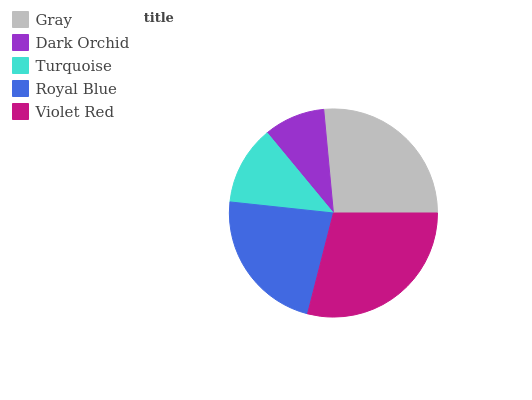Is Dark Orchid the minimum?
Answer yes or no. Yes. Is Violet Red the maximum?
Answer yes or no. Yes. Is Turquoise the minimum?
Answer yes or no. No. Is Turquoise the maximum?
Answer yes or no. No. Is Turquoise greater than Dark Orchid?
Answer yes or no. Yes. Is Dark Orchid less than Turquoise?
Answer yes or no. Yes. Is Dark Orchid greater than Turquoise?
Answer yes or no. No. Is Turquoise less than Dark Orchid?
Answer yes or no. No. Is Royal Blue the high median?
Answer yes or no. Yes. Is Royal Blue the low median?
Answer yes or no. Yes. Is Turquoise the high median?
Answer yes or no. No. Is Gray the low median?
Answer yes or no. No. 